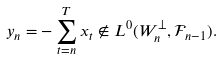<formula> <loc_0><loc_0><loc_500><loc_500>y _ { n } = - \sum _ { t = n } ^ { T } x _ { t } \not \in L ^ { 0 } ( W _ { n } ^ { \perp } , \mathcal { F } _ { n - 1 } ) .</formula> 